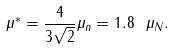<formula> <loc_0><loc_0><loc_500><loc_500>\mu ^ { * } = \frac { 4 } { 3 \sqrt { 2 } } \mu _ { n } = 1 . 8 \ \mu _ { N } .</formula> 